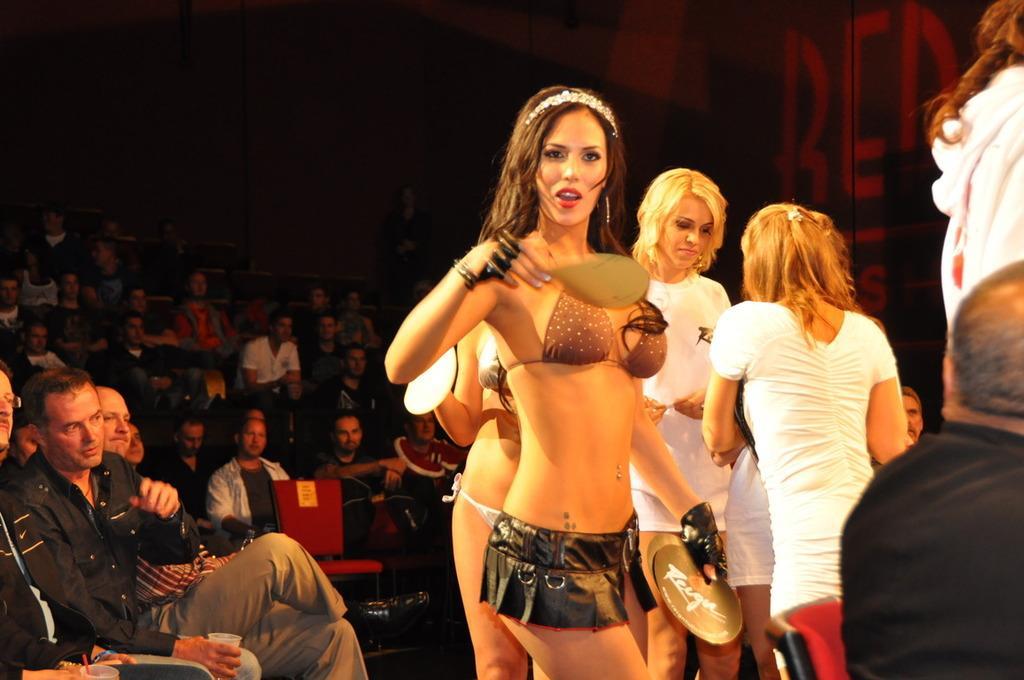In one or two sentences, can you explain what this image depicts? In this picture I can see on the left side a group of people are sitting on the chairs, on the right side there are girls standing, few girls are wearing t-shirts. 